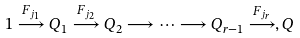Convert formula to latex. <formula><loc_0><loc_0><loc_500><loc_500>1 \stackrel { F _ { j _ { 1 } } } { \longrightarrow } Q _ { 1 } \stackrel { F _ { j _ { 2 } } } { \longrightarrow } Q _ { 2 } \longrightarrow \cdots \longrightarrow Q _ { r - 1 } \stackrel { F _ { j _ { r } } } { \longrightarrow } , Q</formula> 